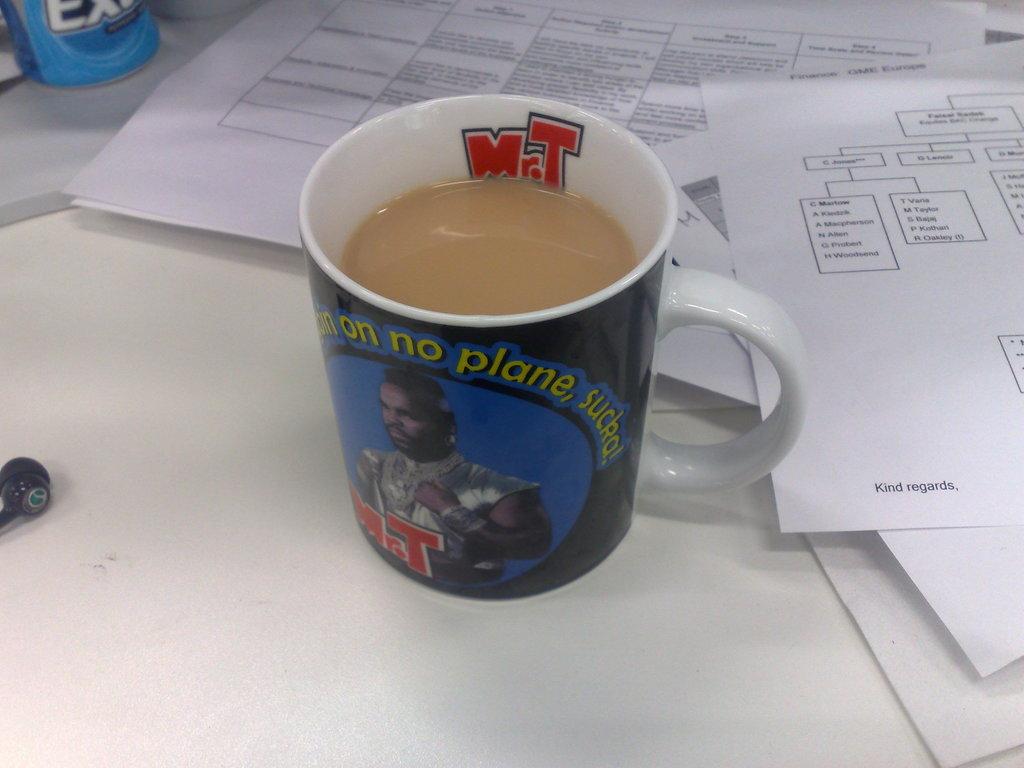What initials are present?
Ensure brevity in your answer.  Mr. t. What is the p word on the cup?
Offer a terse response. Plane. 